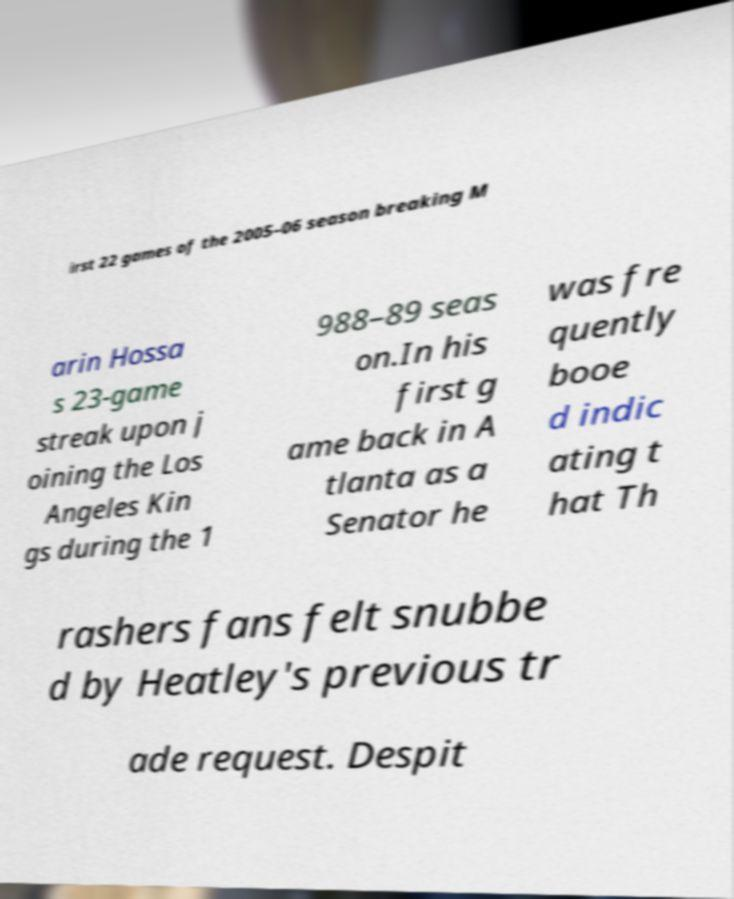What messages or text are displayed in this image? I need them in a readable, typed format. irst 22 games of the 2005–06 season breaking M arin Hossa s 23-game streak upon j oining the Los Angeles Kin gs during the 1 988–89 seas on.In his first g ame back in A tlanta as a Senator he was fre quently booe d indic ating t hat Th rashers fans felt snubbe d by Heatley's previous tr ade request. Despit 